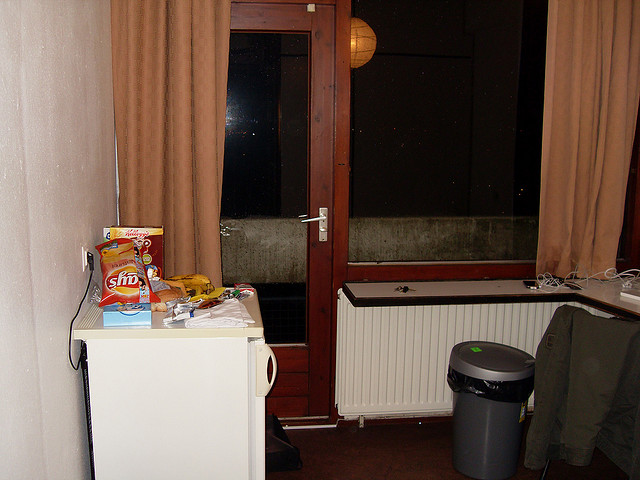<image>What time is it? It is unknown what exact time is it. It could be night or evening. What time is it? I don't know what time it is. It can be nighttime or evening. 